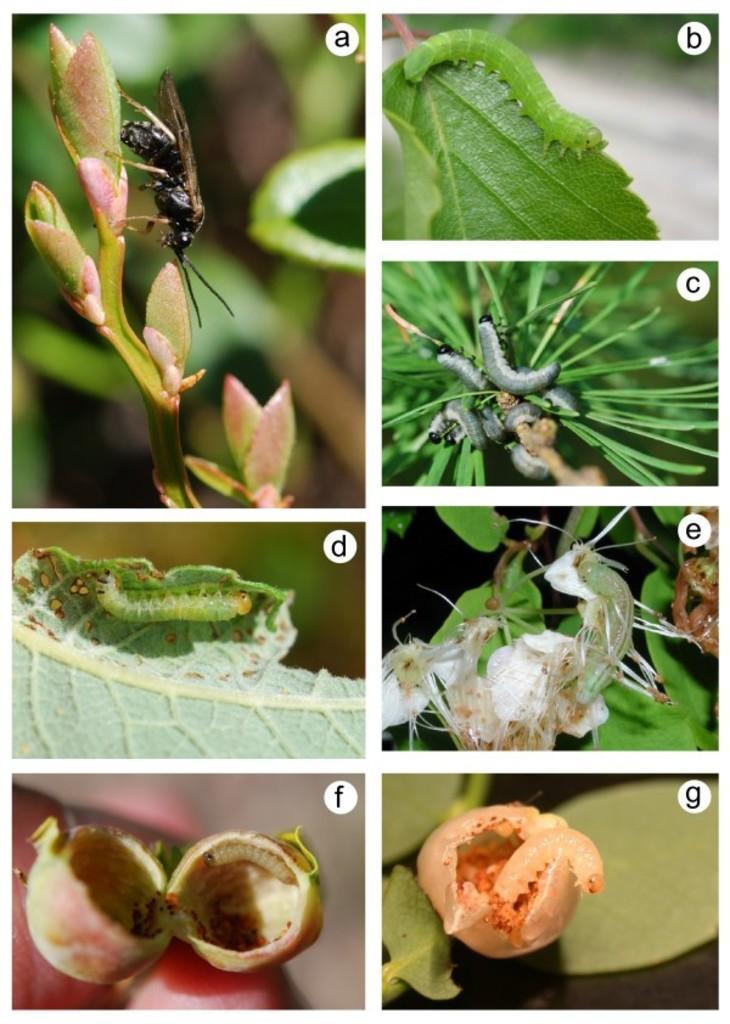Please provide a concise description of this image. This image contains a collage of photos. Left top there is an insect on the plant having leaves. Right top there is a caterpillar on the leaf. Below it there are few caterpillars on the land. Right bottom there is an insect on the leaf. Top it there is an image having few insects on the plants. 